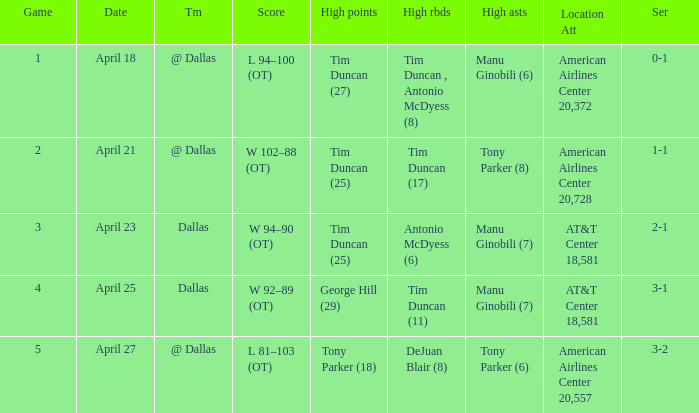When 0-1 is the series who has the highest amount of assists? Manu Ginobili (6). 